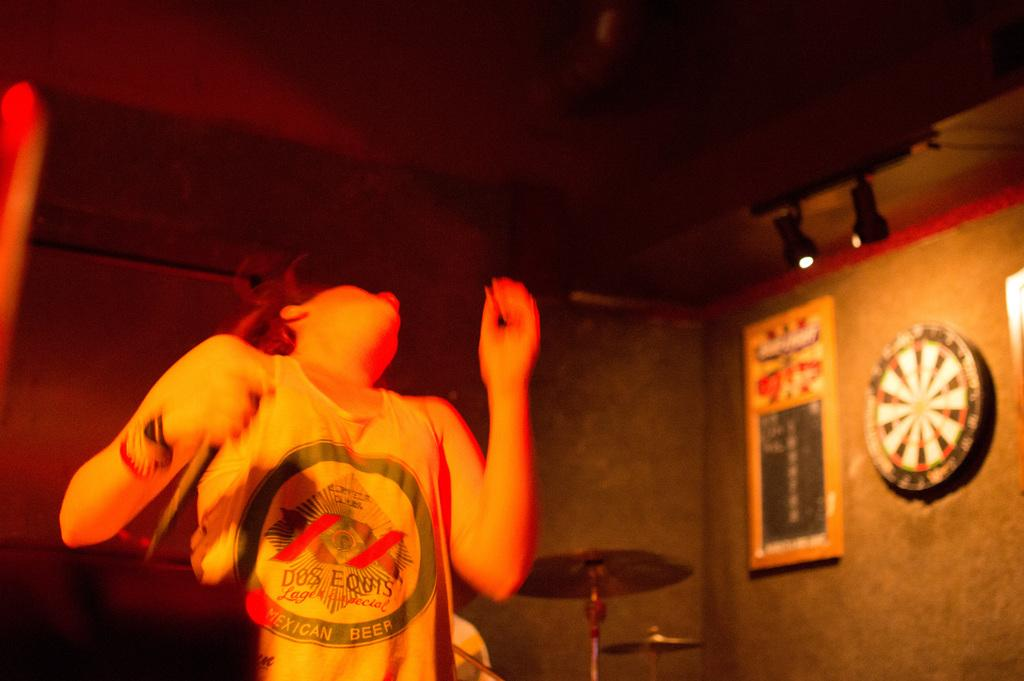What is the person in the image doing? There is a person dancing in the image. What type of clothing is the person wearing? The person is wearing a top. What can be seen on the right side of the image? There are lights on the right side of the image. Can you see any feelings of shame on the person's face while they are dancing in the image? There is no indication of shame or any other emotions on the person's face in the image. Are there any fairies present in the image? There is no mention of fairies or any other mythical creatures in the image. 